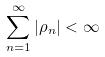<formula> <loc_0><loc_0><loc_500><loc_500>\sum _ { n = 1 } ^ { \infty } | \rho _ { n } | < \infty</formula> 